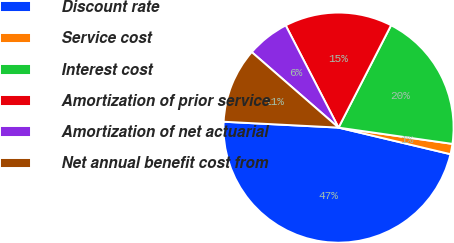Convert chart. <chart><loc_0><loc_0><loc_500><loc_500><pie_chart><fcel>Discount rate<fcel>Service cost<fcel>Interest cost<fcel>Amortization of prior service<fcel>Amortization of net actuarial<fcel>Net annual benefit cost from<nl><fcel>47.1%<fcel>1.45%<fcel>19.71%<fcel>15.14%<fcel>6.01%<fcel>10.58%<nl></chart> 